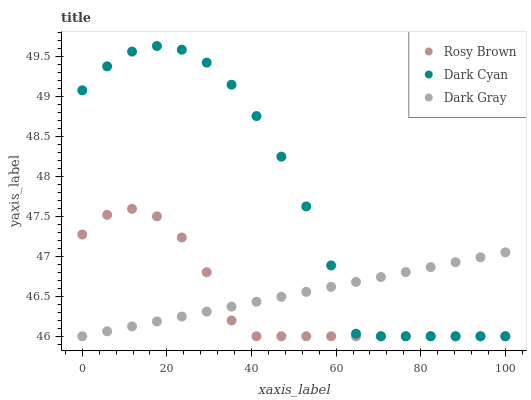Does Rosy Brown have the minimum area under the curve?
Answer yes or no. Yes. Does Dark Cyan have the maximum area under the curve?
Answer yes or no. Yes. Does Dark Gray have the minimum area under the curve?
Answer yes or no. No. Does Dark Gray have the maximum area under the curve?
Answer yes or no. No. Is Dark Gray the smoothest?
Answer yes or no. Yes. Is Dark Cyan the roughest?
Answer yes or no. Yes. Is Rosy Brown the smoothest?
Answer yes or no. No. Is Rosy Brown the roughest?
Answer yes or no. No. Does Dark Cyan have the lowest value?
Answer yes or no. Yes. Does Dark Cyan have the highest value?
Answer yes or no. Yes. Does Rosy Brown have the highest value?
Answer yes or no. No. Does Dark Cyan intersect Rosy Brown?
Answer yes or no. Yes. Is Dark Cyan less than Rosy Brown?
Answer yes or no. No. Is Dark Cyan greater than Rosy Brown?
Answer yes or no. No. 